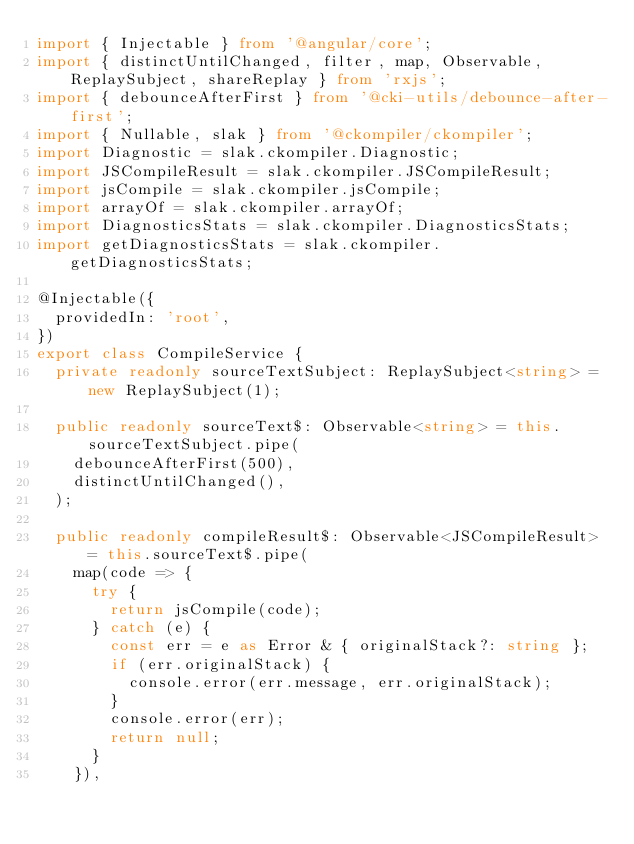<code> <loc_0><loc_0><loc_500><loc_500><_TypeScript_>import { Injectable } from '@angular/core';
import { distinctUntilChanged, filter, map, Observable, ReplaySubject, shareReplay } from 'rxjs';
import { debounceAfterFirst } from '@cki-utils/debounce-after-first';
import { Nullable, slak } from '@ckompiler/ckompiler';
import Diagnostic = slak.ckompiler.Diagnostic;
import JSCompileResult = slak.ckompiler.JSCompileResult;
import jsCompile = slak.ckompiler.jsCompile;
import arrayOf = slak.ckompiler.arrayOf;
import DiagnosticsStats = slak.ckompiler.DiagnosticsStats;
import getDiagnosticsStats = slak.ckompiler.getDiagnosticsStats;

@Injectable({
  providedIn: 'root',
})
export class CompileService {
  private readonly sourceTextSubject: ReplaySubject<string> = new ReplaySubject(1);

  public readonly sourceText$: Observable<string> = this.sourceTextSubject.pipe(
    debounceAfterFirst(500),
    distinctUntilChanged(),
  );

  public readonly compileResult$: Observable<JSCompileResult> = this.sourceText$.pipe(
    map(code => {
      try {
        return jsCompile(code);
      } catch (e) {
        const err = e as Error & { originalStack?: string };
        if (err.originalStack) {
          console.error(err.message, err.originalStack);
        }
        console.error(err);
        return null;
      }
    }),</code> 